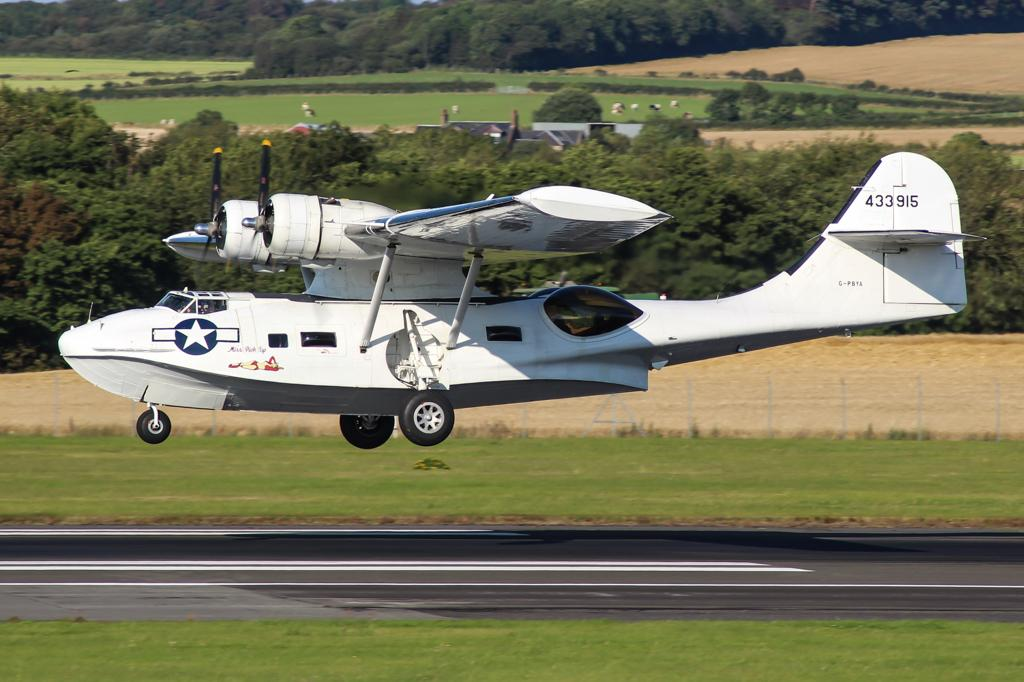What is the main subject in the middle of the image? There is a plane in the middle of the image. What can be seen at the bottom of the image? There is grass and a road at the bottom of the image. What is located behind the plane in the image? There are trees behind the plane. How many bags of popcorn are visible in the image? There are no bags of popcorn present in the image. Can you describe the size of the boy in the image? There is no boy present in the image. 